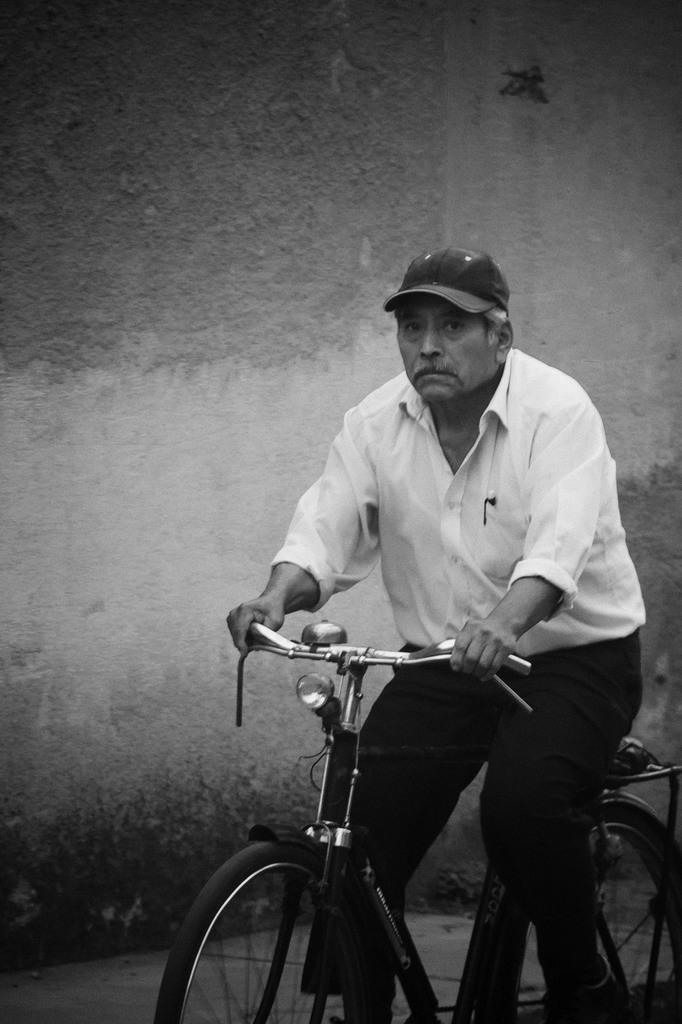How would you summarize this image in a sentence or two? In this image i can see a person wearing a hat, white shirt and black pant is riding a bicycle. In the background i can see a wall. 